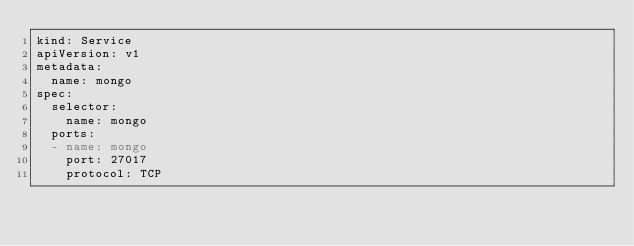<code> <loc_0><loc_0><loc_500><loc_500><_YAML_>kind: Service
apiVersion: v1
metadata:
  name: mongo
spec:
  selector:
    name: mongo
  ports:
  - name: mongo
    port: 27017
    protocol: TCP
</code> 